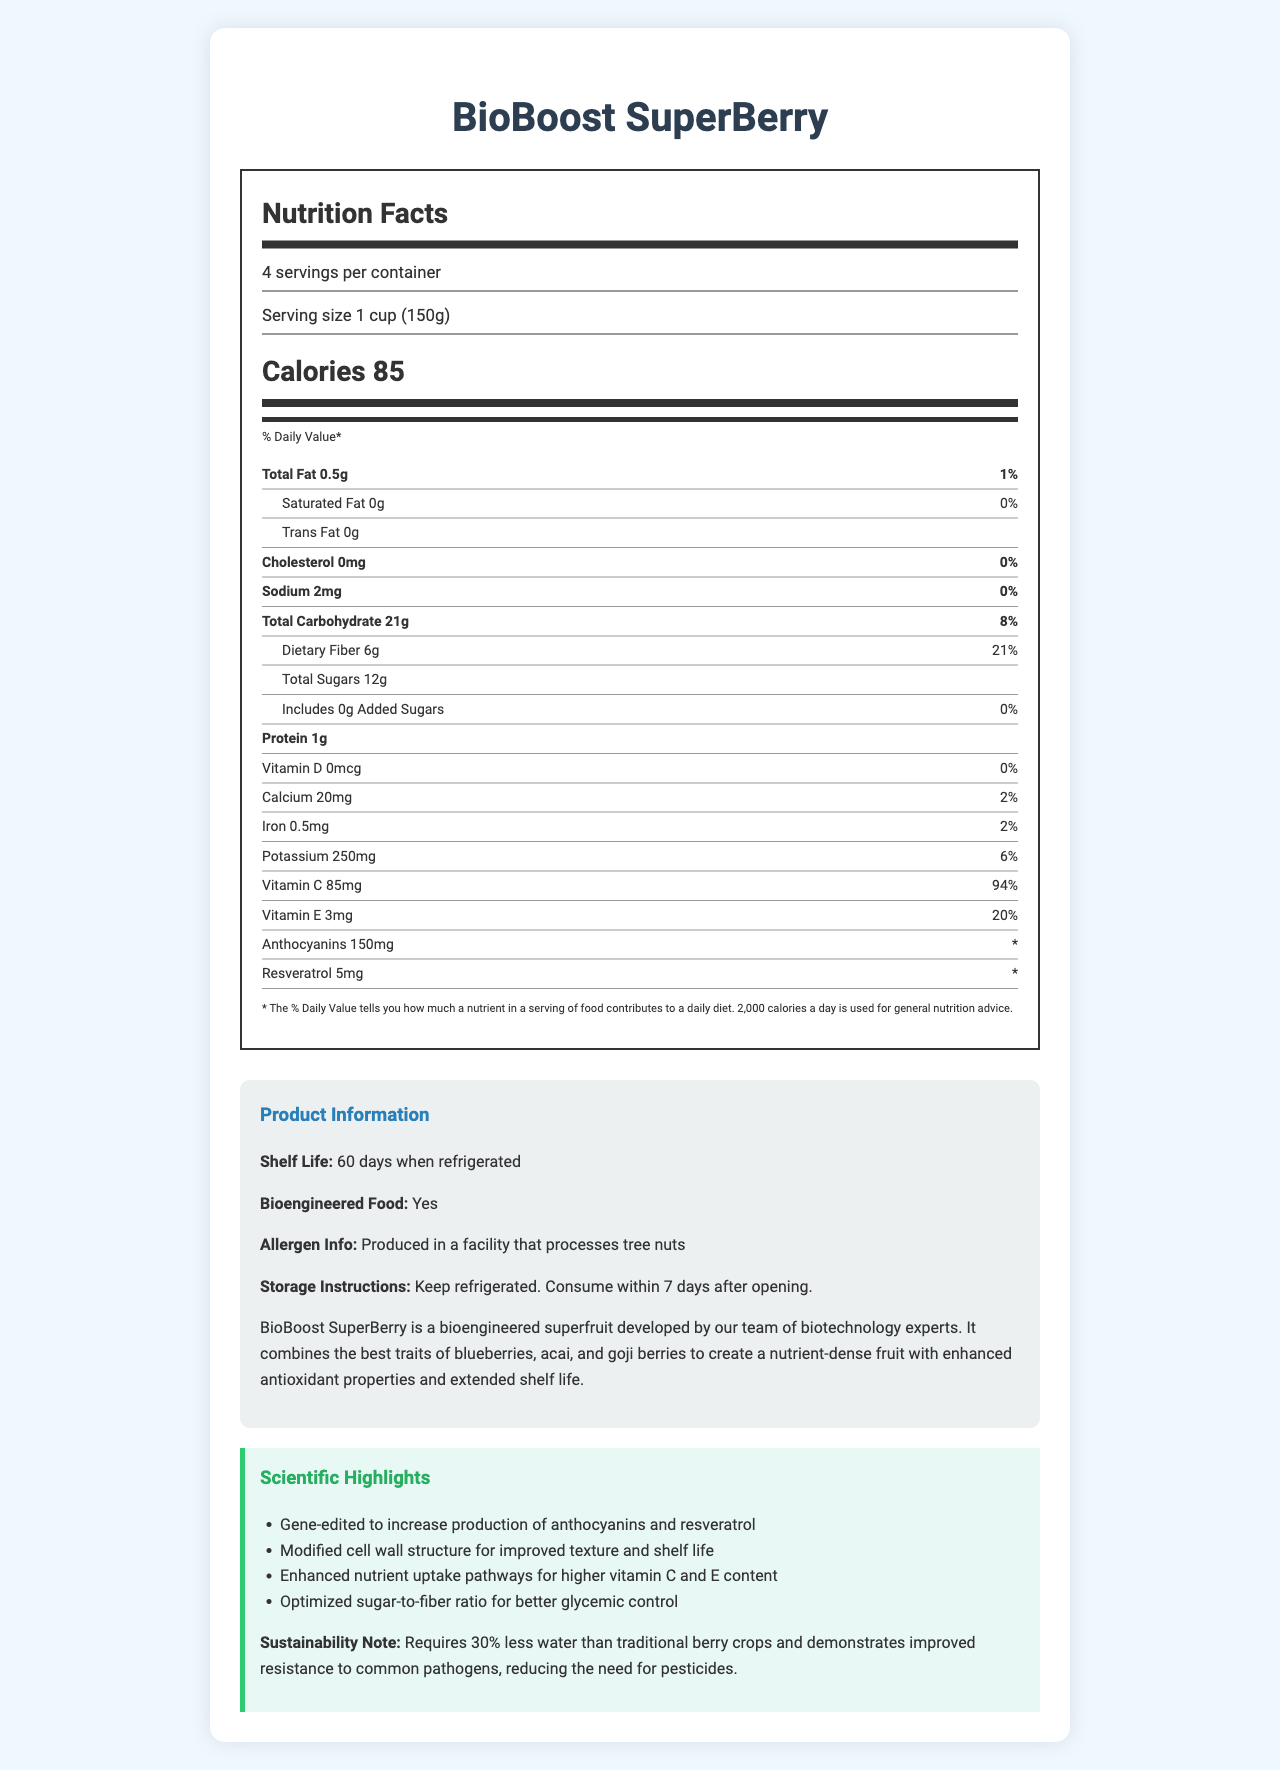What is the serving size of BioBoost SuperBerry? The serving size is explicitly mentioned in the document under the Nutrition Facts section.
Answer: 1 cup (150g) How many calories are in one serving of BioBoost SuperBerry? The calorie count per serving is listed in bold within the Nutrition Facts.
Answer: 85 What is the % Daily Value of Vitamin C in BioBoost SuperBerry? The % Daily Value for Vitamin C is listed under the nutrient breakdown.
Answer: 94% What is the amount of dietary fiber per serving? The amount of dietary fiber is found in the document under the total carbohydrate section.
Answer: 6g Is the product bioengineered? The product information section explicitly states that the product is bioengineered.
Answer: Yes Which nutrient in BioBoost SuperBerry has no daily value percentage listed? A. Anthocyanins B. Vitamin E C. Potassium The daily value for anthocyanins is not provided whereas Potassium and Vitamin E have % daily values.
Answer: A How many servings are in one container of BioBoost SuperBerry? The number of servings per container is provided in the serving information.
Answer: 4 What is the primary ingredient that has been gene-edited in BioBoost SuperBerry? The scientific highlights mention gene-editing to increase production of anthocyanins and resveratrol.
Answer: Anthocyanins True or False: BioBoost SuperBerry contains added sugars. The document states that there are 0g of added sugars.
Answer: False Which vitamin has the highest daily value percentage in BioBoost SuperBerry? A. Vitamin D B. Vitamin E C. Vitamin C Vitamin C has the highest daily value percentage at 94%.
Answer: C Please summarize the main highlights of the BioBoost SuperBerry product. The document provides details on the product's nutritional content, serving information, bioengineered nature, scientific improvements, and sustainability notes, emphasizing its benefits in terms of nutrients and reduced environmental impact.
Answer: The BioBoost SuperBerry Nutrition Facts Label showcases a nutrient-dense bioengineered fruit designed with increased levels of antioxidants such as anthocyanins and resveratrol, extended shelf life, and enhanced nutritional benefits including high levels of Vitamin C and E. The document also highlights its eco-friendliness by requiring less water and fewer pesticides. How much trans fat is in each serving of BioBoost SuperBerry? The trans fat content is listed under the nutrient breakdown as 0g.
Answer: 0g What additional nutrients does BioBoost SuperBerry provide that aren’t typically listed on standard Nutrition Facts labels? These nutrients are listed in the document but are not typically found on standard Nutrition Facts labels.
Answer: Anthocyanins and Resveratrol How long can BioBoost SuperBerry be stored when refrigerated? The product information section states that the shelf life is 60 days when refrigerated.
Answer: 60 days What facility allergen information is mentioned in the label? The allergen information section mentions this specific detail.
Answer: Produced in a facility that processes tree nuts What are the storage instructions for BioBoost SuperBerry after opening? The storage instructions are specifically provided in the product information section.
Answer: Keep refrigerated. Consume within 7 days after opening. Which scientific highlight mentions a structural modification? One of the scientific highlights details this structural modification.
Answer: Modified cell wall structure for improved texture and shelf life Does BioBoost SuperBerry contain iron? If so, how much? The iron content is listed under the nutrient breakdown.
Answer: Yes, 0.5mg Can you determine the exact ingredients list of BioBoost SuperBerry from the document? The document does not provide a detailed list of ingredients, only the nutritional content and scientific modifications.
Answer: Not enough information 